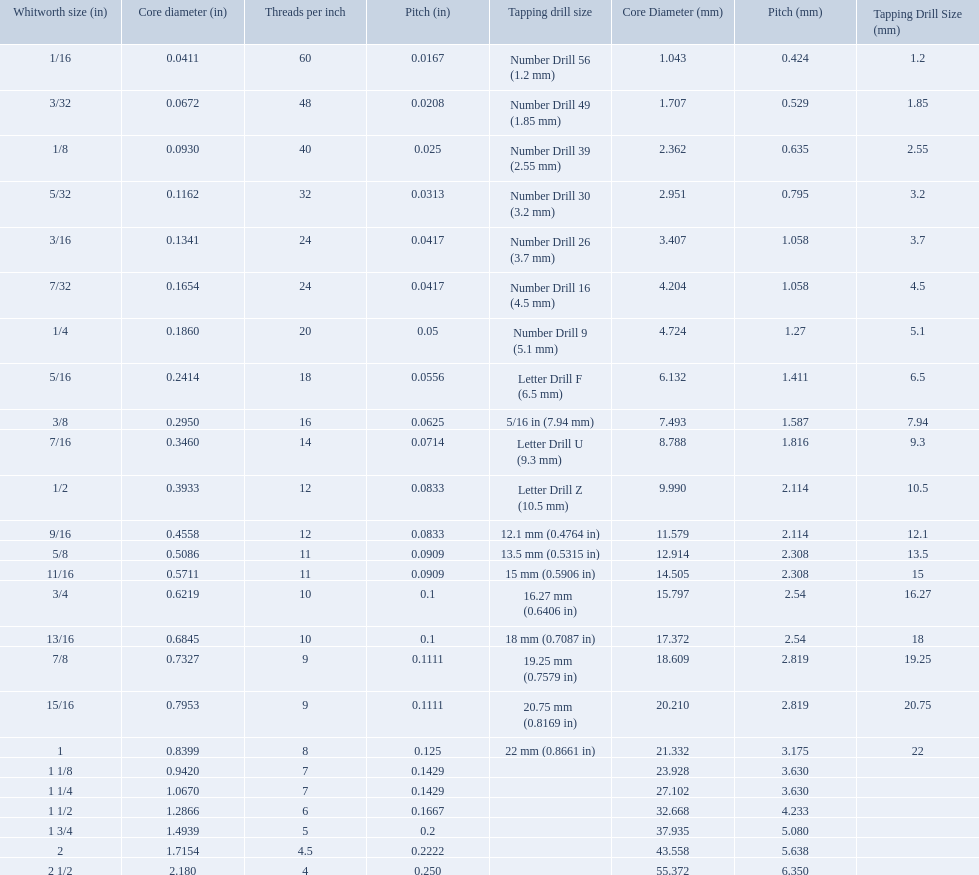What are all of the whitworth sizes? 1/16, 3/32, 1/8, 5/32, 3/16, 7/32, 1/4, 5/16, 3/8, 7/16, 1/2, 9/16, 5/8, 11/16, 3/4, 13/16, 7/8, 15/16, 1, 1 1/8, 1 1/4, 1 1/2, 1 3/4, 2, 2 1/2. How many threads per inch are in each size? 60, 48, 40, 32, 24, 24, 20, 18, 16, 14, 12, 12, 11, 11, 10, 10, 9, 9, 8, 7, 7, 6, 5, 4.5, 4. How many threads per inch are in the 3/16 size? 24. And which other size has the same number of threads? 7/32. A 1/16 whitworth has a core diameter of? 0.0411. Which whiteworth size has the same pitch as a 1/2? 9/16. 3/16 whiteworth has the same number of threads as? 7/32. What are the sizes of threads per inch? 60, 48, 40, 32, 24, 24, 20, 18, 16, 14, 12, 12, 11, 11, 10, 10, 9, 9, 8, 7, 7, 6, 5, 4.5, 4. Which whitworth size has only 5 threads per inch? 1 3/4. What are all the whitworth sizes? 1/16, 3/32, 1/8, 5/32, 3/16, 7/32, 1/4, 5/16, 3/8, 7/16, 1/2, 9/16, 5/8, 11/16, 3/4, 13/16, 7/8, 15/16, 1, 1 1/8, 1 1/4, 1 1/2, 1 3/4, 2, 2 1/2. What are the threads per inch of these sizes? 60, 48, 40, 32, 24, 24, 20, 18, 16, 14, 12, 12, 11, 11, 10, 10, 9, 9, 8, 7, 7, 6, 5, 4.5, 4. Of these, which are 5? 5. What whitworth size has this threads per inch? 1 3/4. What was the core diameter of a number drill 26 0.1341. What is this measurement in whitworth size? 3/16. 